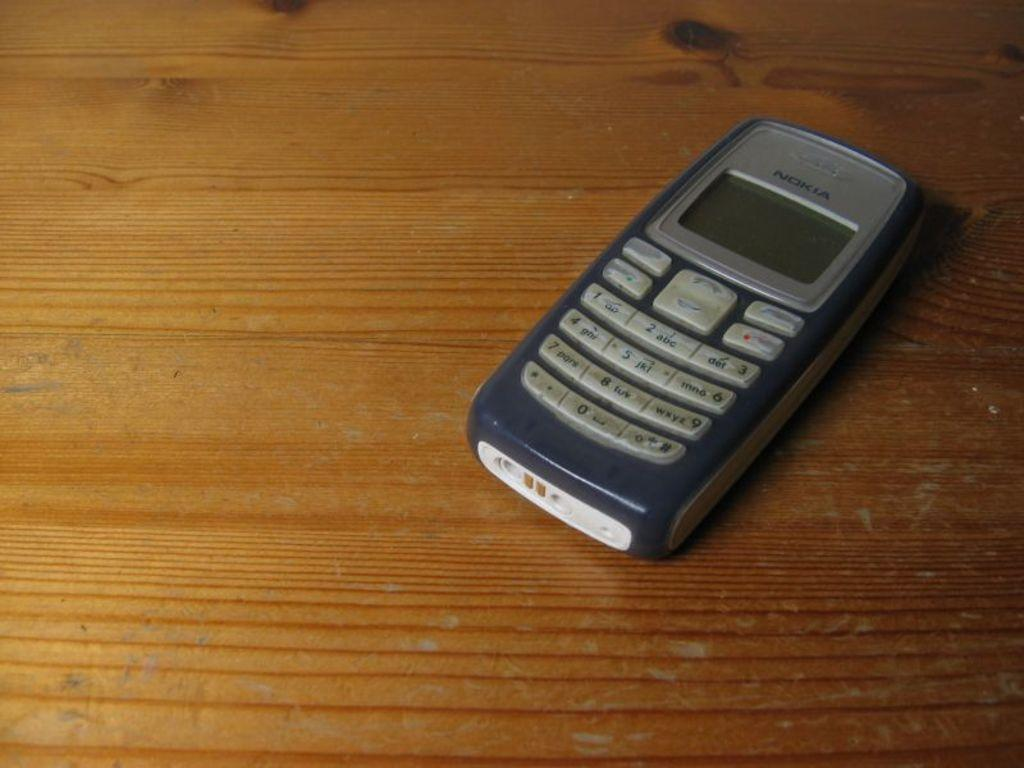<image>
Provide a brief description of the given image. A Nokia cell phone is placed on a wooden surface. 